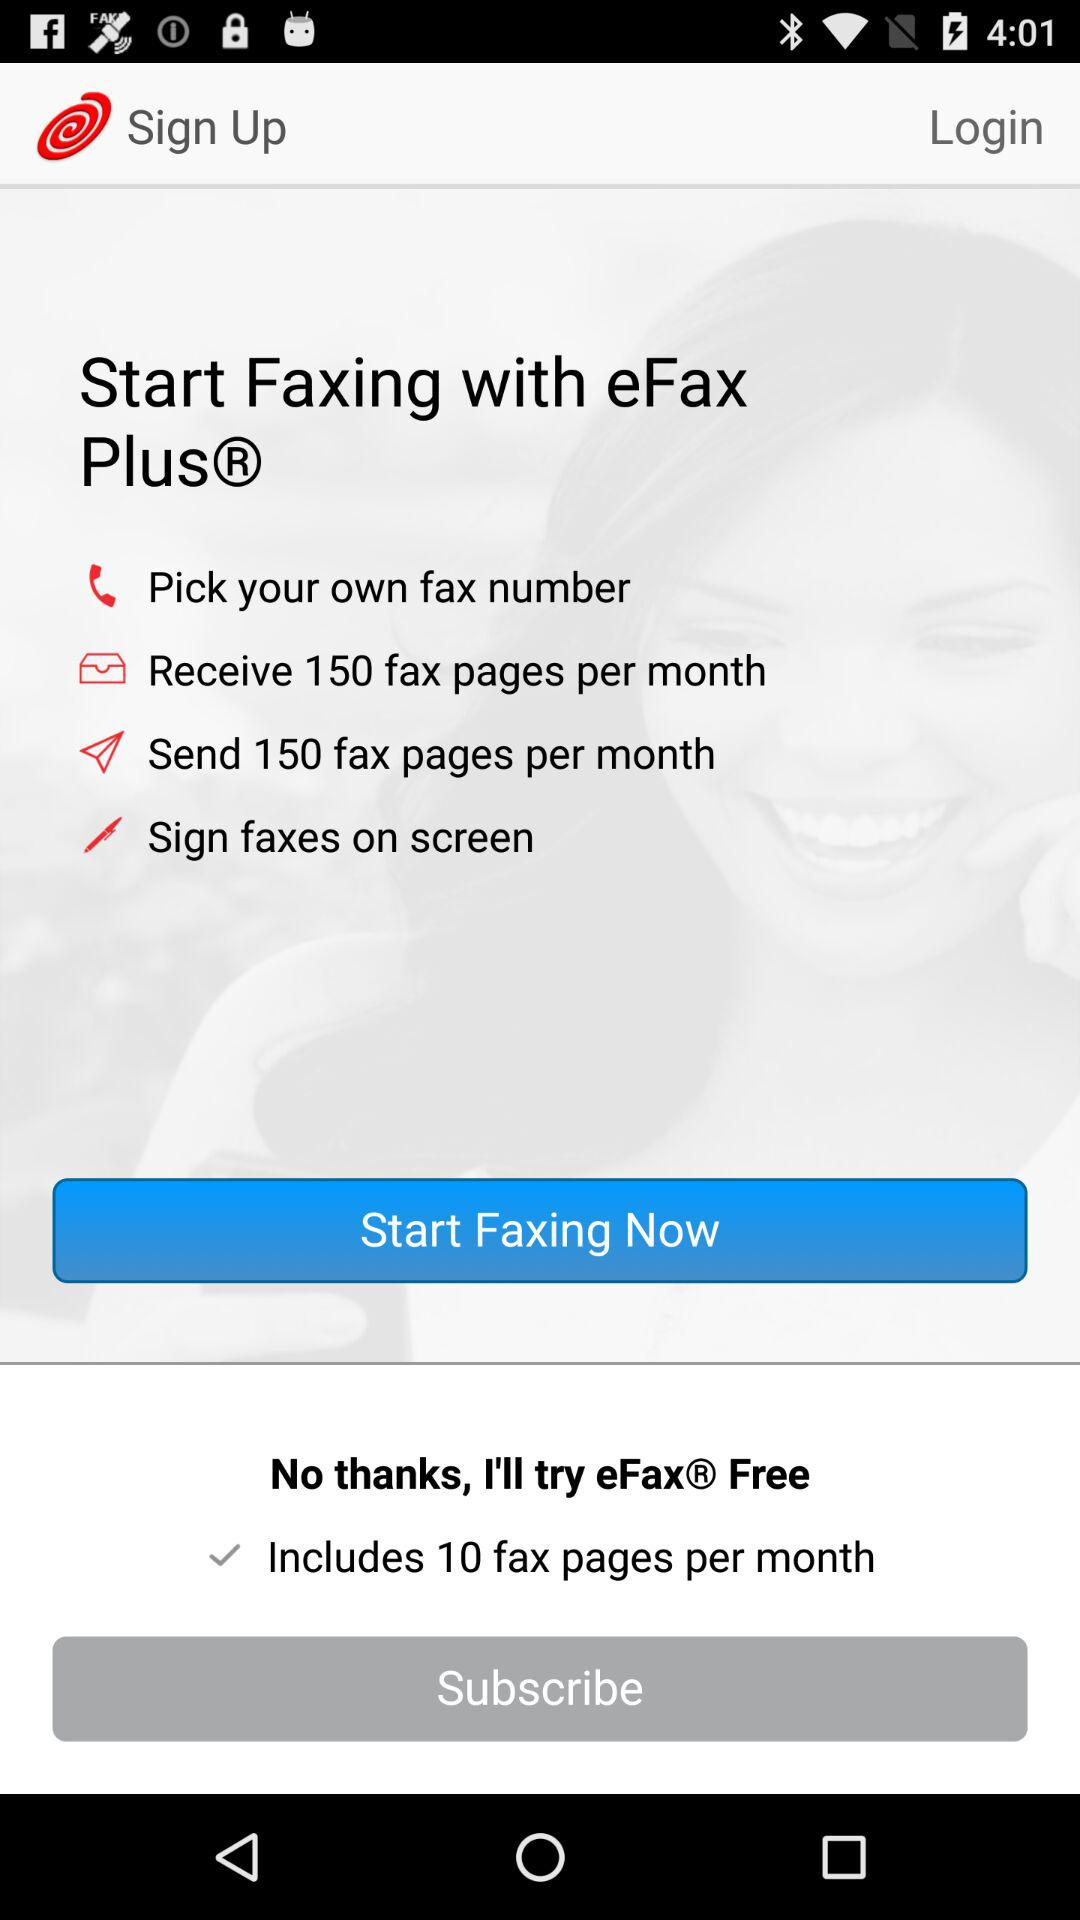How many fax pages are included per month? The number of fax pages that are included per month is 10. 